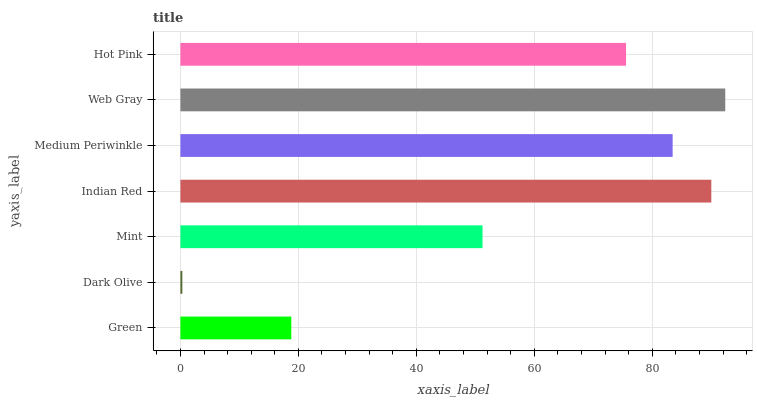Is Dark Olive the minimum?
Answer yes or no. Yes. Is Web Gray the maximum?
Answer yes or no. Yes. Is Mint the minimum?
Answer yes or no. No. Is Mint the maximum?
Answer yes or no. No. Is Mint greater than Dark Olive?
Answer yes or no. Yes. Is Dark Olive less than Mint?
Answer yes or no. Yes. Is Dark Olive greater than Mint?
Answer yes or no. No. Is Mint less than Dark Olive?
Answer yes or no. No. Is Hot Pink the high median?
Answer yes or no. Yes. Is Hot Pink the low median?
Answer yes or no. Yes. Is Web Gray the high median?
Answer yes or no. No. Is Green the low median?
Answer yes or no. No. 